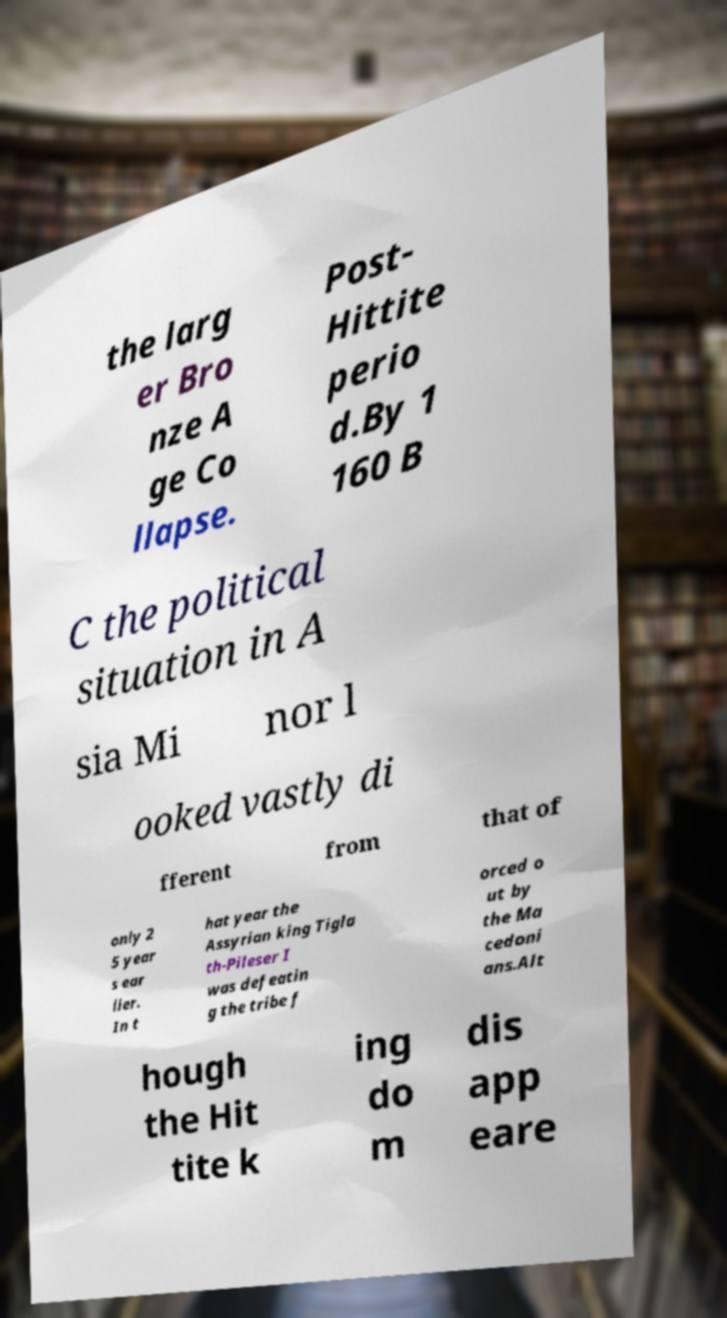Could you assist in decoding the text presented in this image and type it out clearly? the larg er Bro nze A ge Co llapse. Post- Hittite perio d.By 1 160 B C the political situation in A sia Mi nor l ooked vastly di fferent from that of only 2 5 year s ear lier. In t hat year the Assyrian king Tigla th-Pileser I was defeatin g the tribe f orced o ut by the Ma cedoni ans.Alt hough the Hit tite k ing do m dis app eare 